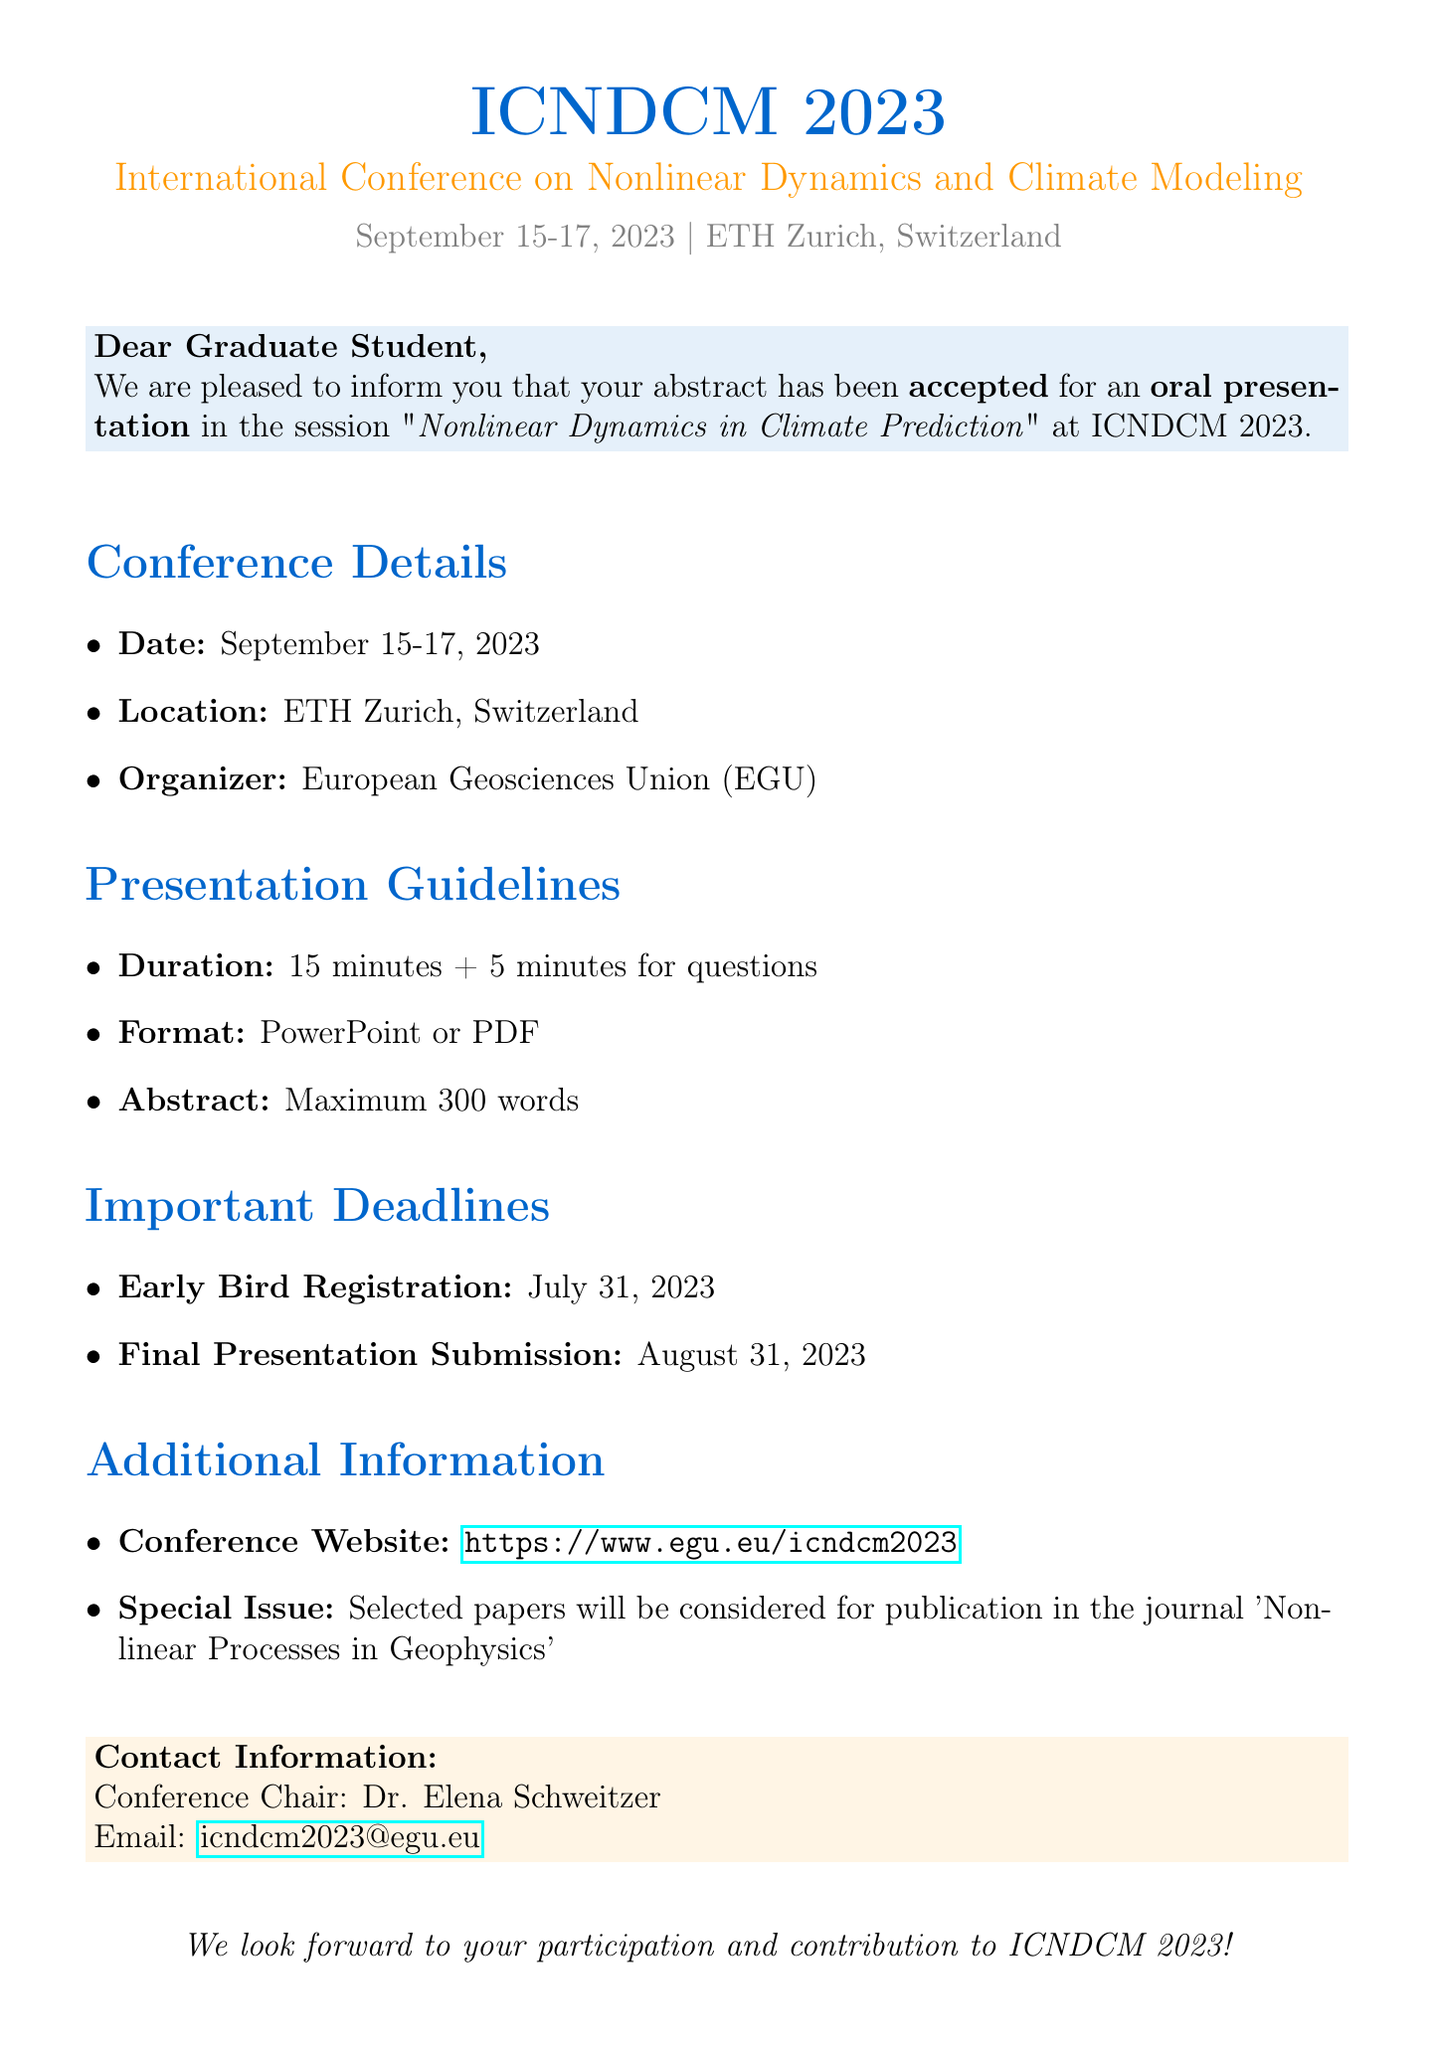What is the name of the conference? The name of the conference is stated at the top of the document.
Answer: International Conference on Nonlinear Dynamics and Climate Modeling (ICNDCM 2023) What is the presentation type? The presentation type is mentioned in the acceptance notification section of the document.
Answer: Oral presentation What are the presentation duration details? The presentation duration details are provided under the presentation guidelines section in the document.
Answer: 15 minutes + 5 minutes for questions When is the conference date? The conference date is listed under the conference details section in the document.
Answer: September 15-17, 2023 Who is the conference chair? The name of the conference chair is mentioned in the contact information section of the document.
Answer: Dr. Elena Schweitzer What is the early bird registration deadline? The early bird registration deadline is outlined in the important deadlines section of the document.
Answer: July 31, 2023 What file format is accepted for presentations? The accepted file format is specified in the presentation guidelines section of the document.
Answer: PowerPoint or PDF Which journal will consider selected papers for publication? The journal for potential publication of selected papers is mentioned in the additional information section of the document.
Answer: Nonlinear Processes in Geophysics What is the location of the conference? The conference location is provided in the conference details section of the document.
Answer: ETH Zurich, Switzerland 